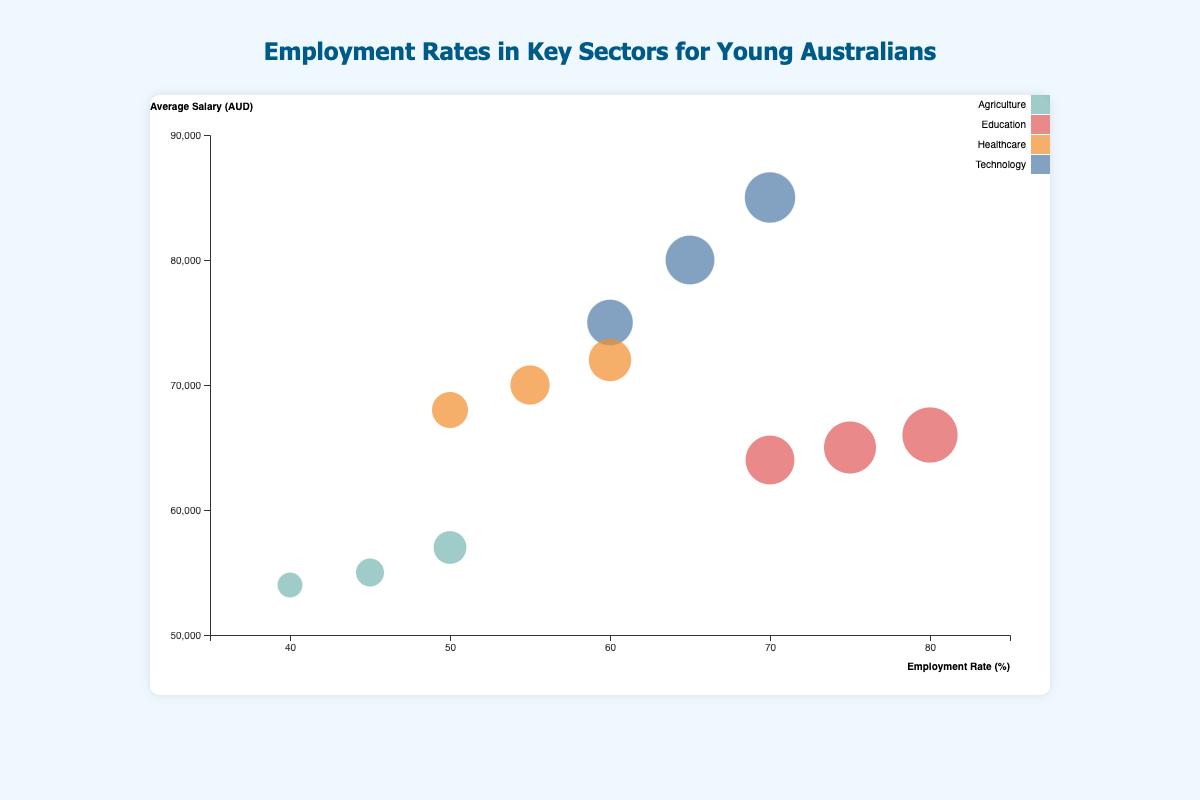What is the title of the chart? The title of the chart is located at the top and is typically clear and concise. Here, the text at the top center reads "Employment Rates in Key Sectors for Young Australians".
Answer: Employment Rates in Key Sectors for Young Australians Which sector has the highest employment rate in Sydney? To find this, examine the bubbles representing Sydney in the chart. Look at the employment rates associated with each sector. Education has an employment rate of 75% in Sydney, which is the highest among all listed sectors.
Answer: Education How does the average salary in Technology in Melbourne compare to that in Brisbane? First, find the average salary for Technology in Melbourne and Brisbane. The chart shows $85,000 for Melbourne and $75,000 for Brisbane. Comparing these two, Melbourne has a higher average salary.
Answer: Melbourne has a higher average salary What's the range of job satisfaction across all sectors in the chart? Identify the highest and lowest job satisfaction values across all sectors in the data. The highest job satisfaction is 82% (in Education, Melbourne) and the lowest is 63% (in Agriculture, Perth). Thus, the range is 82% - 63%.
Answer: 19% Which sector and location combination has the lowest employment rate and what is the average salary there? Look for the bubble with the lowest employment rate in the chart. Agriculture in Perth has the lowest employment rate at 40%. The average salary for this combination is also listed and is $54,000.
Answer: Agriculture in Perth, $54,000 Compare the job satisfaction between the highest employment rate and the lowest employment rate sectors. Identify the sector with the highest employment rate (Education in Melbourne at 80%) and the lowest employment rate (Agriculture in Perth at 40%). The job satisfaction for these sectors is 82% and 63% respectively.
Answer: 82% and 63% How many sectors have an employment rate of at least 60% in Melbourne? Examine the employment rates for sectors in Melbourne. Technology, Healthcare, and Education all meet or exceed 60%.
Answer: 3 sectors Which sector has the highest job satisfaction and in which location? Look at the bubbles to identify the highest job satisfaction percentage. It is 82% in the Education sector in Melbourne.
Answer: Education, Melbourne What is the average salary for the Technology sector across all listed locations (Sydney, Melbourne, Brisbane)? Average salary is computed for Technology in Sydney ($80,000), Melbourne ($85,000), and Brisbane ($75,000). Sum these up to get $240,000, then divide by the number of locations (3).
Answer: $80,000 